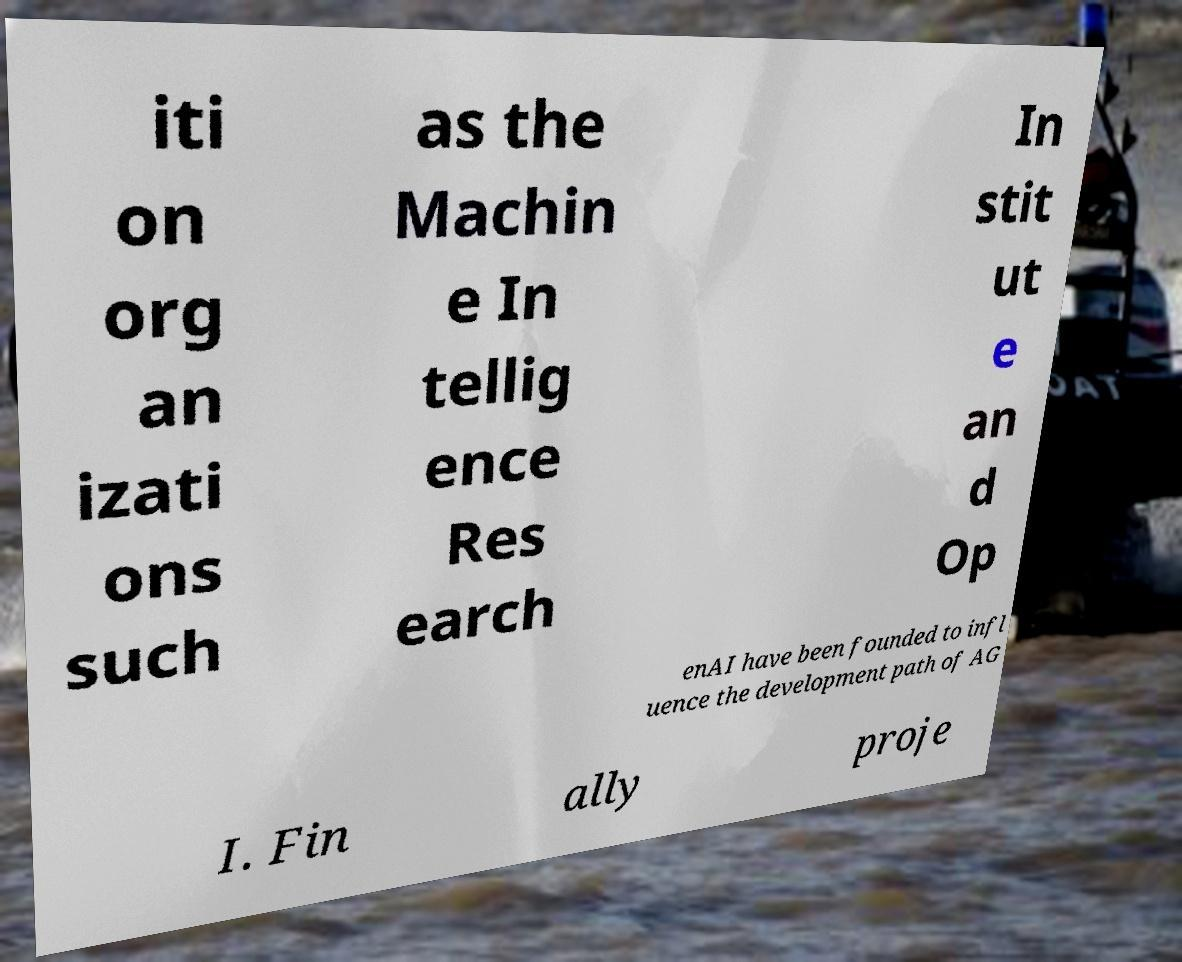I need the written content from this picture converted into text. Can you do that? iti on org an izati ons such as the Machin e In tellig ence Res earch In stit ut e an d Op enAI have been founded to infl uence the development path of AG I. Fin ally proje 